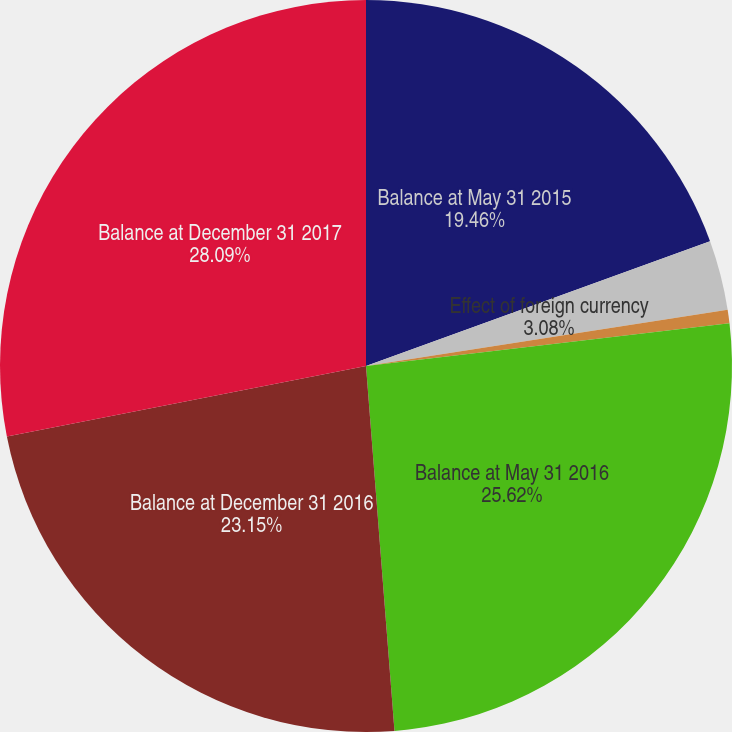<chart> <loc_0><loc_0><loc_500><loc_500><pie_chart><fcel>Balance at May 31 2015<fcel>Effect of foreign currency<fcel>Measurement-period adjustments<fcel>Balance at May 31 2016<fcel>Balance at December 31 2016<fcel>Balance at December 31 2017<nl><fcel>19.46%<fcel>3.08%<fcel>0.6%<fcel>25.62%<fcel>23.15%<fcel>28.09%<nl></chart> 